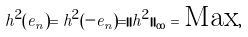Convert formula to latex. <formula><loc_0><loc_0><loc_500><loc_500>h ^ { 2 } ( e _ { n } ) = h ^ { 2 } ( - e _ { n } ) = | | h ^ { 2 } | | _ { \infty } = \text {Max} ,</formula> 